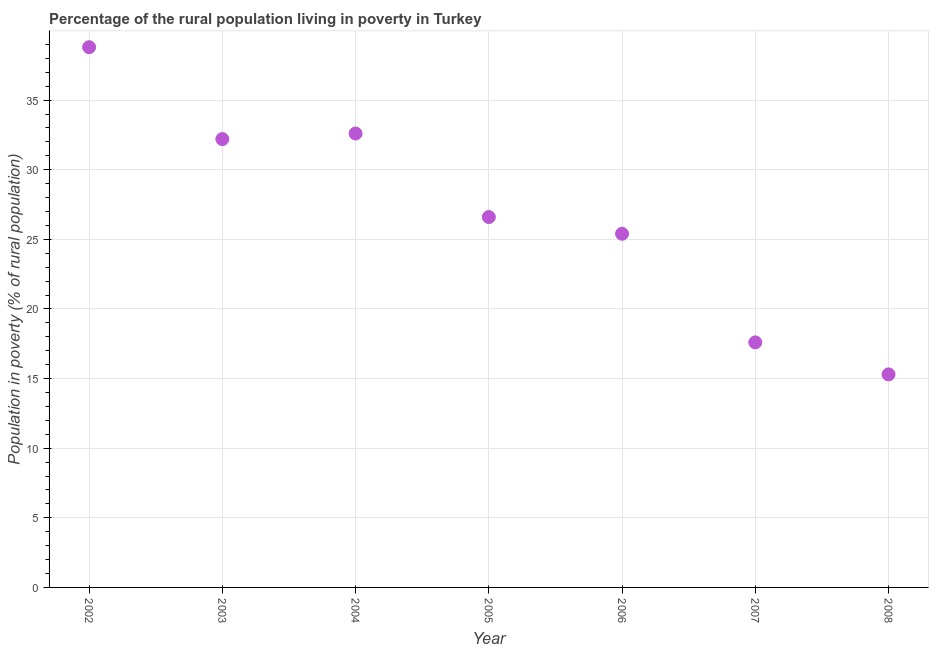What is the percentage of rural population living below poverty line in 2006?
Give a very brief answer. 25.4. Across all years, what is the maximum percentage of rural population living below poverty line?
Keep it short and to the point. 38.8. Across all years, what is the minimum percentage of rural population living below poverty line?
Your answer should be compact. 15.3. In which year was the percentage of rural population living below poverty line maximum?
Keep it short and to the point. 2002. What is the sum of the percentage of rural population living below poverty line?
Give a very brief answer. 188.5. What is the difference between the percentage of rural population living below poverty line in 2006 and 2007?
Your answer should be compact. 7.8. What is the average percentage of rural population living below poverty line per year?
Ensure brevity in your answer.  26.93. What is the median percentage of rural population living below poverty line?
Offer a very short reply. 26.6. In how many years, is the percentage of rural population living below poverty line greater than 19 %?
Offer a terse response. 5. What is the ratio of the percentage of rural population living below poverty line in 2003 to that in 2007?
Give a very brief answer. 1.83. What is the difference between the highest and the second highest percentage of rural population living below poverty line?
Make the answer very short. 6.2. What is the difference between the highest and the lowest percentage of rural population living below poverty line?
Provide a succinct answer. 23.5. In how many years, is the percentage of rural population living below poverty line greater than the average percentage of rural population living below poverty line taken over all years?
Keep it short and to the point. 3. How many dotlines are there?
Offer a very short reply. 1. What is the difference between two consecutive major ticks on the Y-axis?
Provide a short and direct response. 5. What is the title of the graph?
Give a very brief answer. Percentage of the rural population living in poverty in Turkey. What is the label or title of the X-axis?
Give a very brief answer. Year. What is the label or title of the Y-axis?
Your answer should be compact. Population in poverty (% of rural population). What is the Population in poverty (% of rural population) in 2002?
Offer a terse response. 38.8. What is the Population in poverty (% of rural population) in 2003?
Offer a very short reply. 32.2. What is the Population in poverty (% of rural population) in 2004?
Your response must be concise. 32.6. What is the Population in poverty (% of rural population) in 2005?
Provide a short and direct response. 26.6. What is the Population in poverty (% of rural population) in 2006?
Offer a very short reply. 25.4. What is the difference between the Population in poverty (% of rural population) in 2002 and 2004?
Give a very brief answer. 6.2. What is the difference between the Population in poverty (% of rural population) in 2002 and 2007?
Provide a succinct answer. 21.2. What is the difference between the Population in poverty (% of rural population) in 2002 and 2008?
Offer a terse response. 23.5. What is the difference between the Population in poverty (% of rural population) in 2003 and 2007?
Give a very brief answer. 14.6. What is the difference between the Population in poverty (% of rural population) in 2004 and 2006?
Your answer should be compact. 7.2. What is the difference between the Population in poverty (% of rural population) in 2004 and 2007?
Your response must be concise. 15. What is the difference between the Population in poverty (% of rural population) in 2004 and 2008?
Provide a short and direct response. 17.3. What is the difference between the Population in poverty (% of rural population) in 2005 and 2006?
Provide a short and direct response. 1.2. What is the difference between the Population in poverty (% of rural population) in 2005 and 2008?
Offer a very short reply. 11.3. What is the difference between the Population in poverty (% of rural population) in 2006 and 2007?
Offer a terse response. 7.8. What is the difference between the Population in poverty (% of rural population) in 2006 and 2008?
Offer a very short reply. 10.1. What is the ratio of the Population in poverty (% of rural population) in 2002 to that in 2003?
Give a very brief answer. 1.21. What is the ratio of the Population in poverty (% of rural population) in 2002 to that in 2004?
Provide a succinct answer. 1.19. What is the ratio of the Population in poverty (% of rural population) in 2002 to that in 2005?
Offer a terse response. 1.46. What is the ratio of the Population in poverty (% of rural population) in 2002 to that in 2006?
Make the answer very short. 1.53. What is the ratio of the Population in poverty (% of rural population) in 2002 to that in 2007?
Your answer should be compact. 2.21. What is the ratio of the Population in poverty (% of rural population) in 2002 to that in 2008?
Give a very brief answer. 2.54. What is the ratio of the Population in poverty (% of rural population) in 2003 to that in 2004?
Ensure brevity in your answer.  0.99. What is the ratio of the Population in poverty (% of rural population) in 2003 to that in 2005?
Ensure brevity in your answer.  1.21. What is the ratio of the Population in poverty (% of rural population) in 2003 to that in 2006?
Your response must be concise. 1.27. What is the ratio of the Population in poverty (% of rural population) in 2003 to that in 2007?
Your response must be concise. 1.83. What is the ratio of the Population in poverty (% of rural population) in 2003 to that in 2008?
Provide a succinct answer. 2.1. What is the ratio of the Population in poverty (% of rural population) in 2004 to that in 2005?
Make the answer very short. 1.23. What is the ratio of the Population in poverty (% of rural population) in 2004 to that in 2006?
Your answer should be very brief. 1.28. What is the ratio of the Population in poverty (% of rural population) in 2004 to that in 2007?
Offer a very short reply. 1.85. What is the ratio of the Population in poverty (% of rural population) in 2004 to that in 2008?
Your response must be concise. 2.13. What is the ratio of the Population in poverty (% of rural population) in 2005 to that in 2006?
Offer a very short reply. 1.05. What is the ratio of the Population in poverty (% of rural population) in 2005 to that in 2007?
Ensure brevity in your answer.  1.51. What is the ratio of the Population in poverty (% of rural population) in 2005 to that in 2008?
Ensure brevity in your answer.  1.74. What is the ratio of the Population in poverty (% of rural population) in 2006 to that in 2007?
Your response must be concise. 1.44. What is the ratio of the Population in poverty (% of rural population) in 2006 to that in 2008?
Offer a very short reply. 1.66. What is the ratio of the Population in poverty (% of rural population) in 2007 to that in 2008?
Your answer should be very brief. 1.15. 